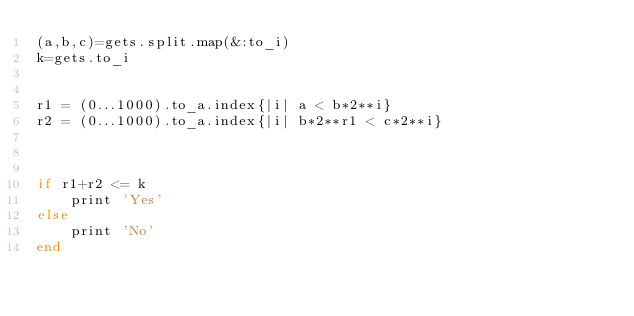Convert code to text. <code><loc_0><loc_0><loc_500><loc_500><_Ruby_>(a,b,c)=gets.split.map(&:to_i)
k=gets.to_i


r1 = (0...1000).to_a.index{|i| a < b*2**i} 
r2 = (0...1000).to_a.index{|i| b*2**r1 < c*2**i} 



if r1+r2 <= k
    print 'Yes'
else
    print 'No'
end</code> 